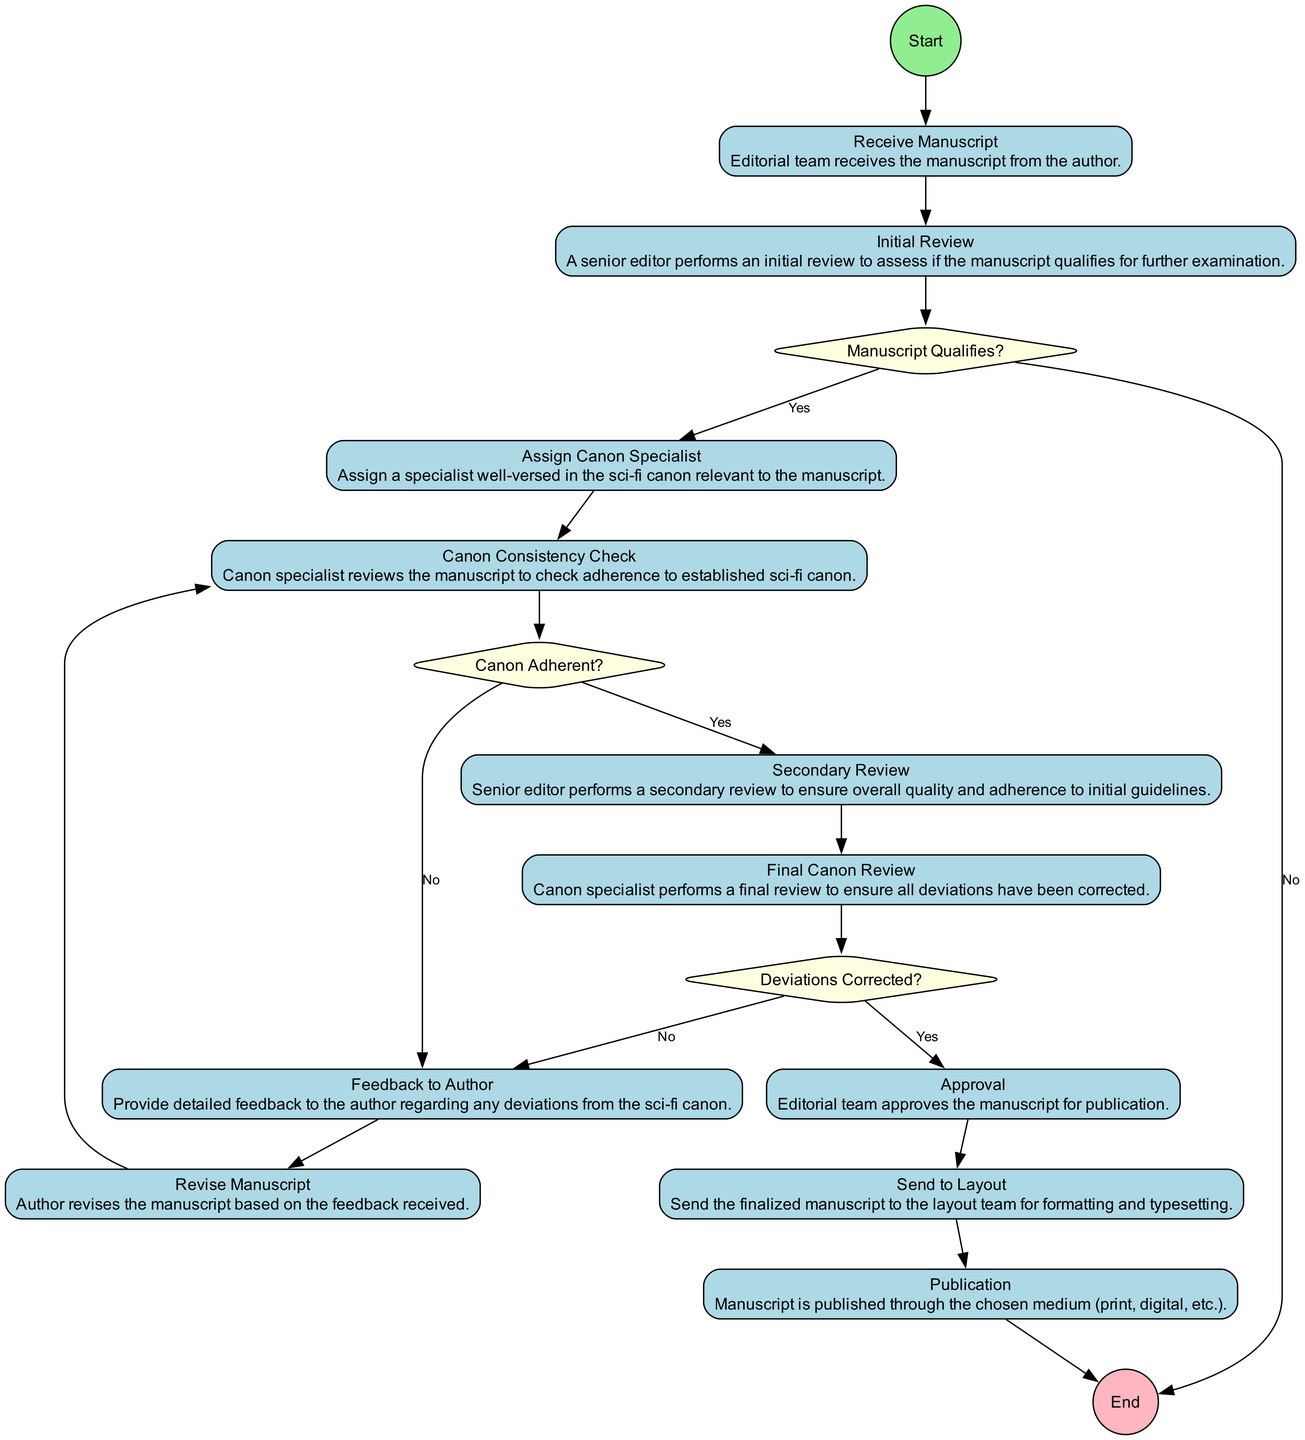what is the first activity in the workflow? The first activity listed in the diagram is "Receive Manuscript," which represents the starting point of the editorial workflow.
Answer: Receive Manuscript how many decision points are present in the diagram? There are three decision points labeled "Manuscript Qualifies?", "Canon Adherent?", and "Deviations Corrected?" which confirm the critical checks during the workflow.
Answer: 3 which activity follows the "Canon Consistency Check"? Based on the flow, "Canon Consistency Check" leads to the decision point "Canon Adherent?", indicating what happens after this check.
Answer: Canon Adherent? if the manuscript does not qualify, where does it lead next? The "Manuscript Qualifies?" decision leads to "End" if the manuscript does not qualify for a detailed review. Therefore, it terminates the process at that point.
Answer: End what is the last step before publication? The last activity before reaching the final stage of publication is "Send to Layout," which is crucial for preparing the manuscript for its final form.
Answer: Send to Layout how many activities are there in total? The total number of activities listed in the workflow is ten, encompassing all editorial tasks from manuscript reception to publication.
Answer: 10 what happens if deviations are found in the final canon review? If deviations are detected in the "Final Canon Review," the process returns to "Feedback to Author," prompting the author to make necessary revisions.
Answer: Feedback to Author which role performs the "Final Canon Review"? The "Final Canon Review" is executed by the canon specialist, whose duty is to ensure that all corrections align with the established sci-fi canon.
Answer: Canon specialist 